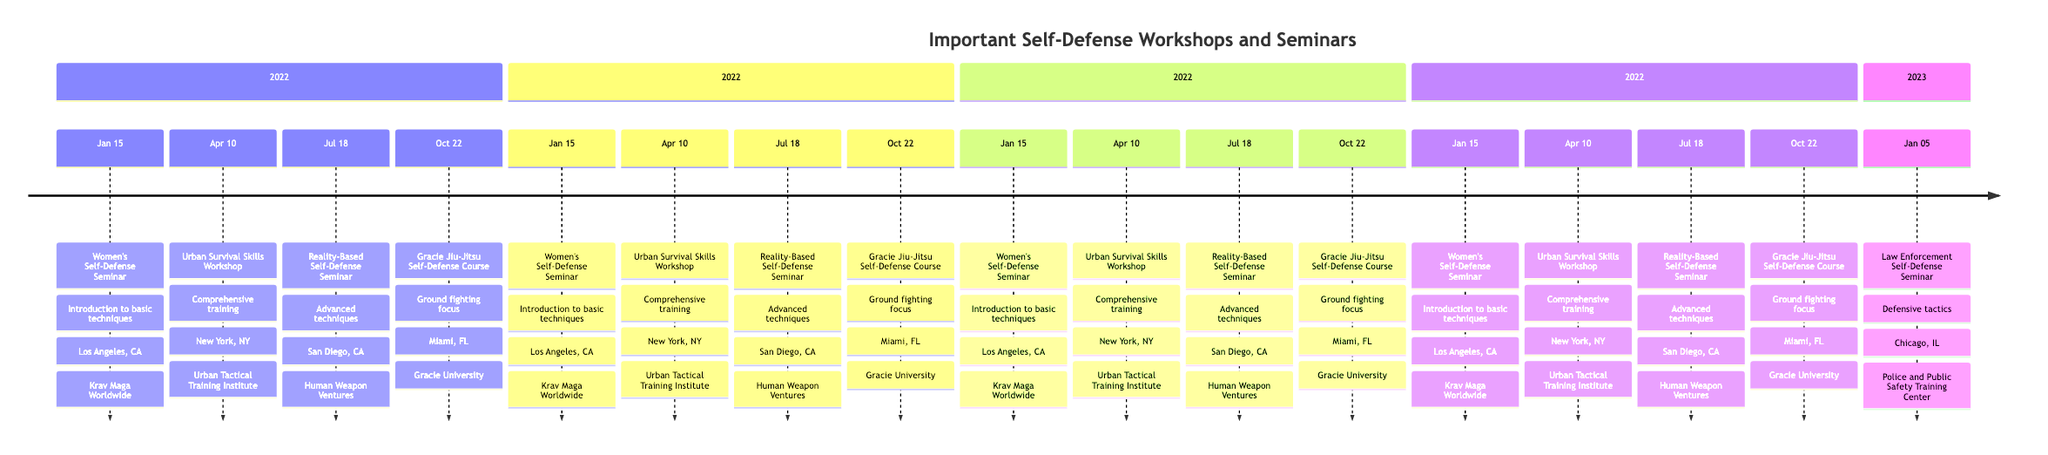What is the title of the workshop held on January 15, 2022? The title of the workshop on this date is mentioned at the start of the corresponding entry in the timeline. Looking at the first entry, it states "Women's Self-Defense Seminar."
Answer: Women's Self-Defense Seminar Where was the "Urban Survival Skills Workshop" held? To find the location of the "Urban Survival Skills Workshop," refer to its entry on April 10, 2022. The entry specifies that it took place in "New York, NY."
Answer: New York, NY Which organization organized the "Gracie Jiu-Jitsu Self-Defense Course"? The organizer's name is indicated next to the course title in the timeline entry. For the "Gracie Jiu-Jitsu Self-Defense Course" scheduled on October 22, 2022, it states that it was organized by "Gracie University."
Answer: Gracie University How many workshops or seminars are listed in the timeline? Count the number of entries in the timeline to determine the total number of workshops and seminars. There are five distinct entries, covering various dates and events.
Answer: 5 What was the focus of the "Reality-Based Self-Defense Seminar"? The focus of this seminar can be found in the description of the entry corresponding to July 18, 2022. It mentions "advanced self-defense techniques and psychological strategies."
Answer: Advanced self-defense techniques and psychological strategies Which seminar took place most recently? To identify the most recent seminar, examine the dates listed in the timeline and find the most current one. The last entry is dated January 5, 2023, indicating it is the most recent.
Answer: Law Enforcement Self-Defense Seminar What overall skill set did the workshops aim to address? By analyzing the descriptions in each entry, it becomes clear that they collectively aim to address self-defense techniques, emergency preparedness, and strategies for real-world situations. This is a summary based on the commonalities across the workshops.
Answer: Self-defense techniques and emergency preparedness Which location hosted the "Law Enforcement Self-Defense Seminar"? Check the entry for the "Law Enforcement Self-Defense Seminar" for its specified location. This seminar took place in "Chicago, IL" as noted in the timeline.
Answer: Chicago, IL 